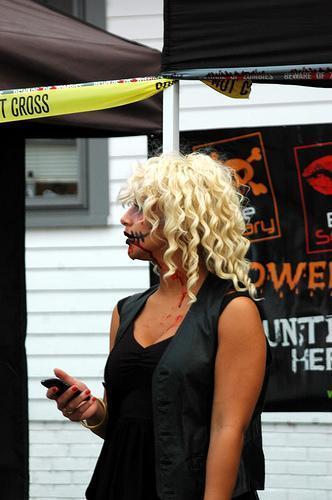How many phones does the woman have?
Give a very brief answer. 1. How many people are holding phone?
Give a very brief answer. 1. 